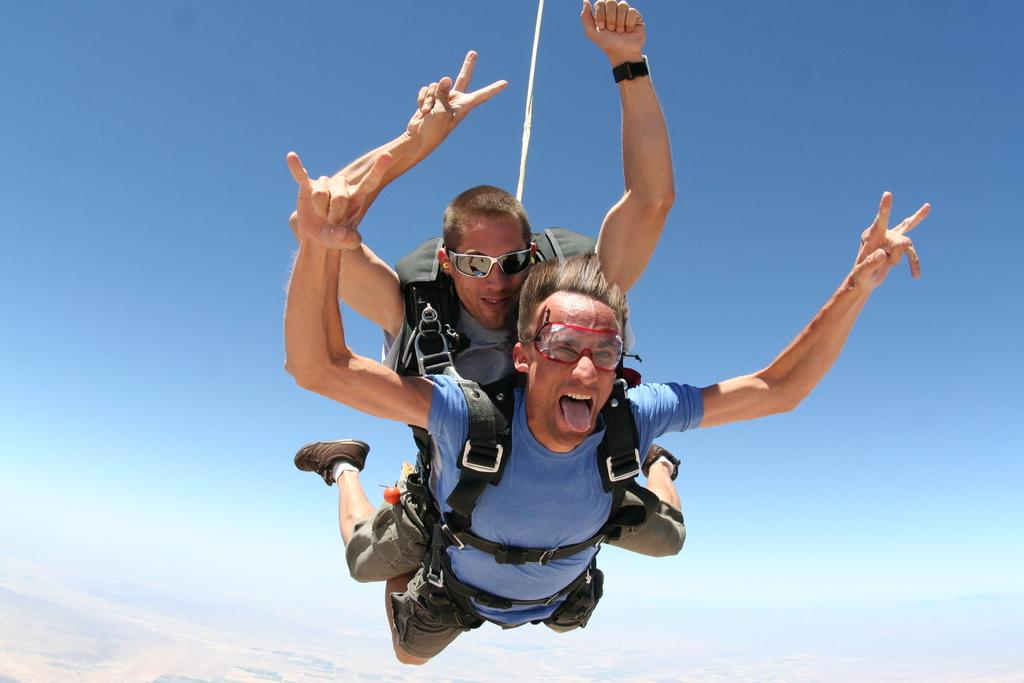How many people are in the image? There are two men in the image. What are the men doing in the image? The men are flying in the air. What are the men wearing to ensure their safety while flying? The men are wearing parachutes. Can you describe the position of the two men in relation to each other? One man is lying above the other. What type of clover can be seen growing on the ground in the image? There is no clover visible in the image, as the men are flying in the air. Can you tell me the level of expertise of the men in the image? The level of expertise of the men cannot be determined from the image alone. 